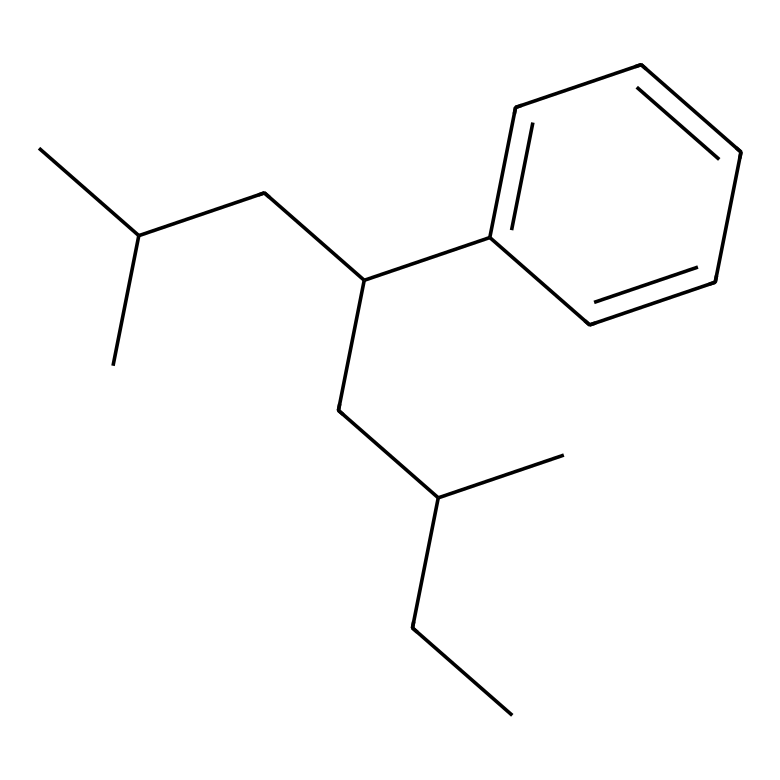What is the primary structural feature of this chemical? The chemical features a branched alkane structure with multiple carbons, indicating it's a highly branched polymer.
Answer: branched alkane How many carbon atoms are present in this chemical? Count the number of carbon atoms in the SMILES representation: CC(C)CC(c1ccccc1)CC(C)CC reveals 21 carbon atoms.
Answer: 21 What type of molecular structure does this chemical represent? The SMILES reflects a structure typical of a synthetic rubber, mainly due to the branching and presence of aromatic rings.
Answer: synthetic rubber How many rings are present in the structure? Observing the c1ccccc1 part of the SMILES denotes a single aromatic ring within the chemical structure.
Answer: 1 What type of polymerization likely created this compound? The structure suggests that it was formed through step-growth polymerization, given the branched nature and functionality in the aromatic component.
Answer: step-growth What role does the aromatic ring play in the properties of this chemical? The aromatic ring contributes to increased stiffness and thermal stability, which enhances durability in garden hoses and outdoor furniture.
Answer: durability 